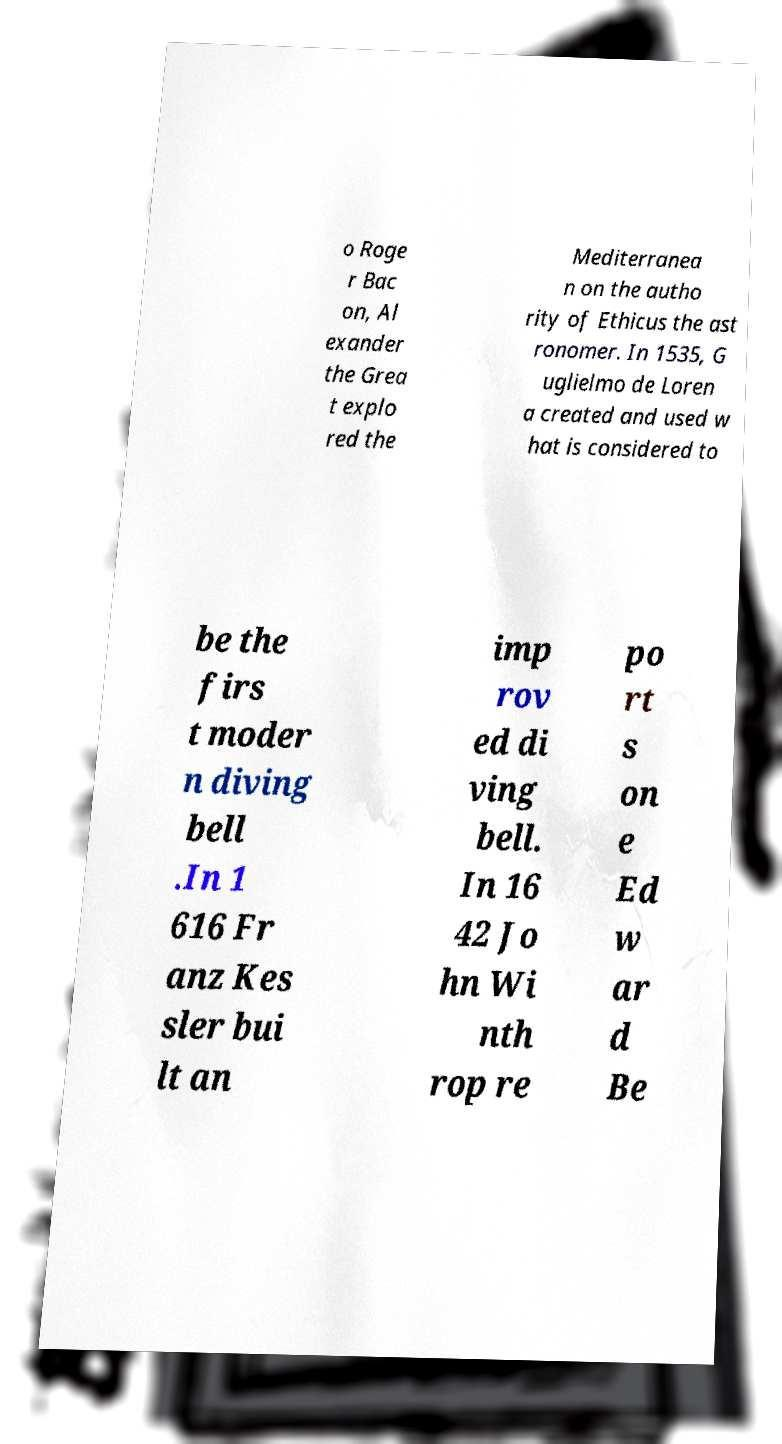What messages or text are displayed in this image? I need them in a readable, typed format. o Roge r Bac on, Al exander the Grea t explo red the Mediterranea n on the autho rity of Ethicus the ast ronomer. In 1535, G uglielmo de Loren a created and used w hat is considered to be the firs t moder n diving bell .In 1 616 Fr anz Kes sler bui lt an imp rov ed di ving bell. In 16 42 Jo hn Wi nth rop re po rt s on e Ed w ar d Be 